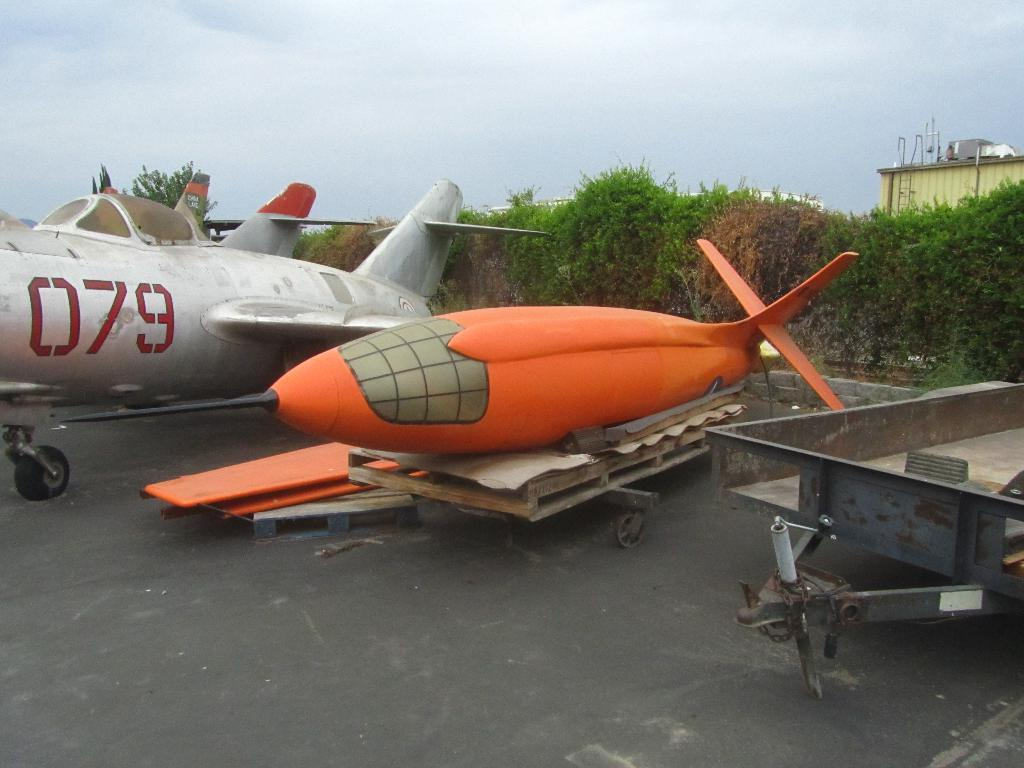<image>
Offer a succinct explanation of the picture presented. Two airplanes, including number 079, are in need of repair in a parking lot. 